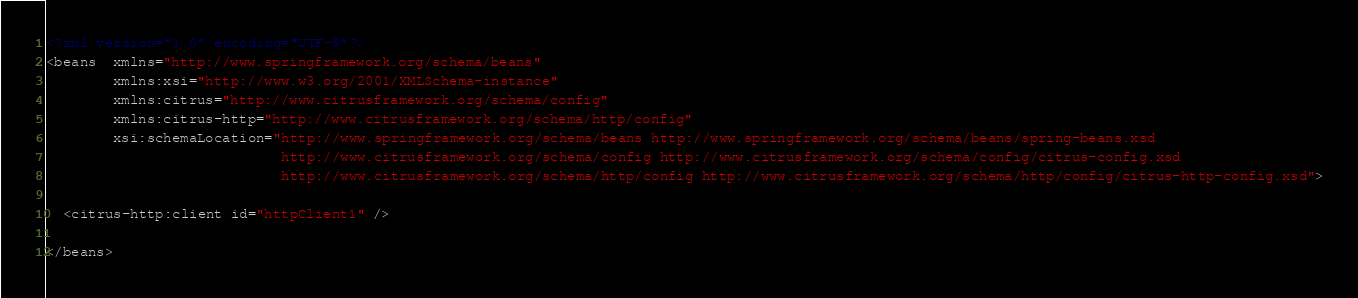Convert code to text. <code><loc_0><loc_0><loc_500><loc_500><_XML_><?xml version="1.0" encoding="UTF-8"?>
<beans  xmlns="http://www.springframework.org/schema/beans"
        xmlns:xsi="http://www.w3.org/2001/XMLSchema-instance"
        xmlns:citrus="http://www.citrusframework.org/schema/config"
        xmlns:citrus-http="http://www.citrusframework.org/schema/http/config"
        xsi:schemaLocation="http://www.springframework.org/schema/beans http://www.springframework.org/schema/beans/spring-beans.xsd
                            http://www.citrusframework.org/schema/config http://www.citrusframework.org/schema/config/citrus-config.xsd
                            http://www.citrusframework.org/schema/http/config http://www.citrusframework.org/schema/http/config/citrus-http-config.xsd">

  <citrus-http:client id="httpClient1" />

</beans>
</code> 